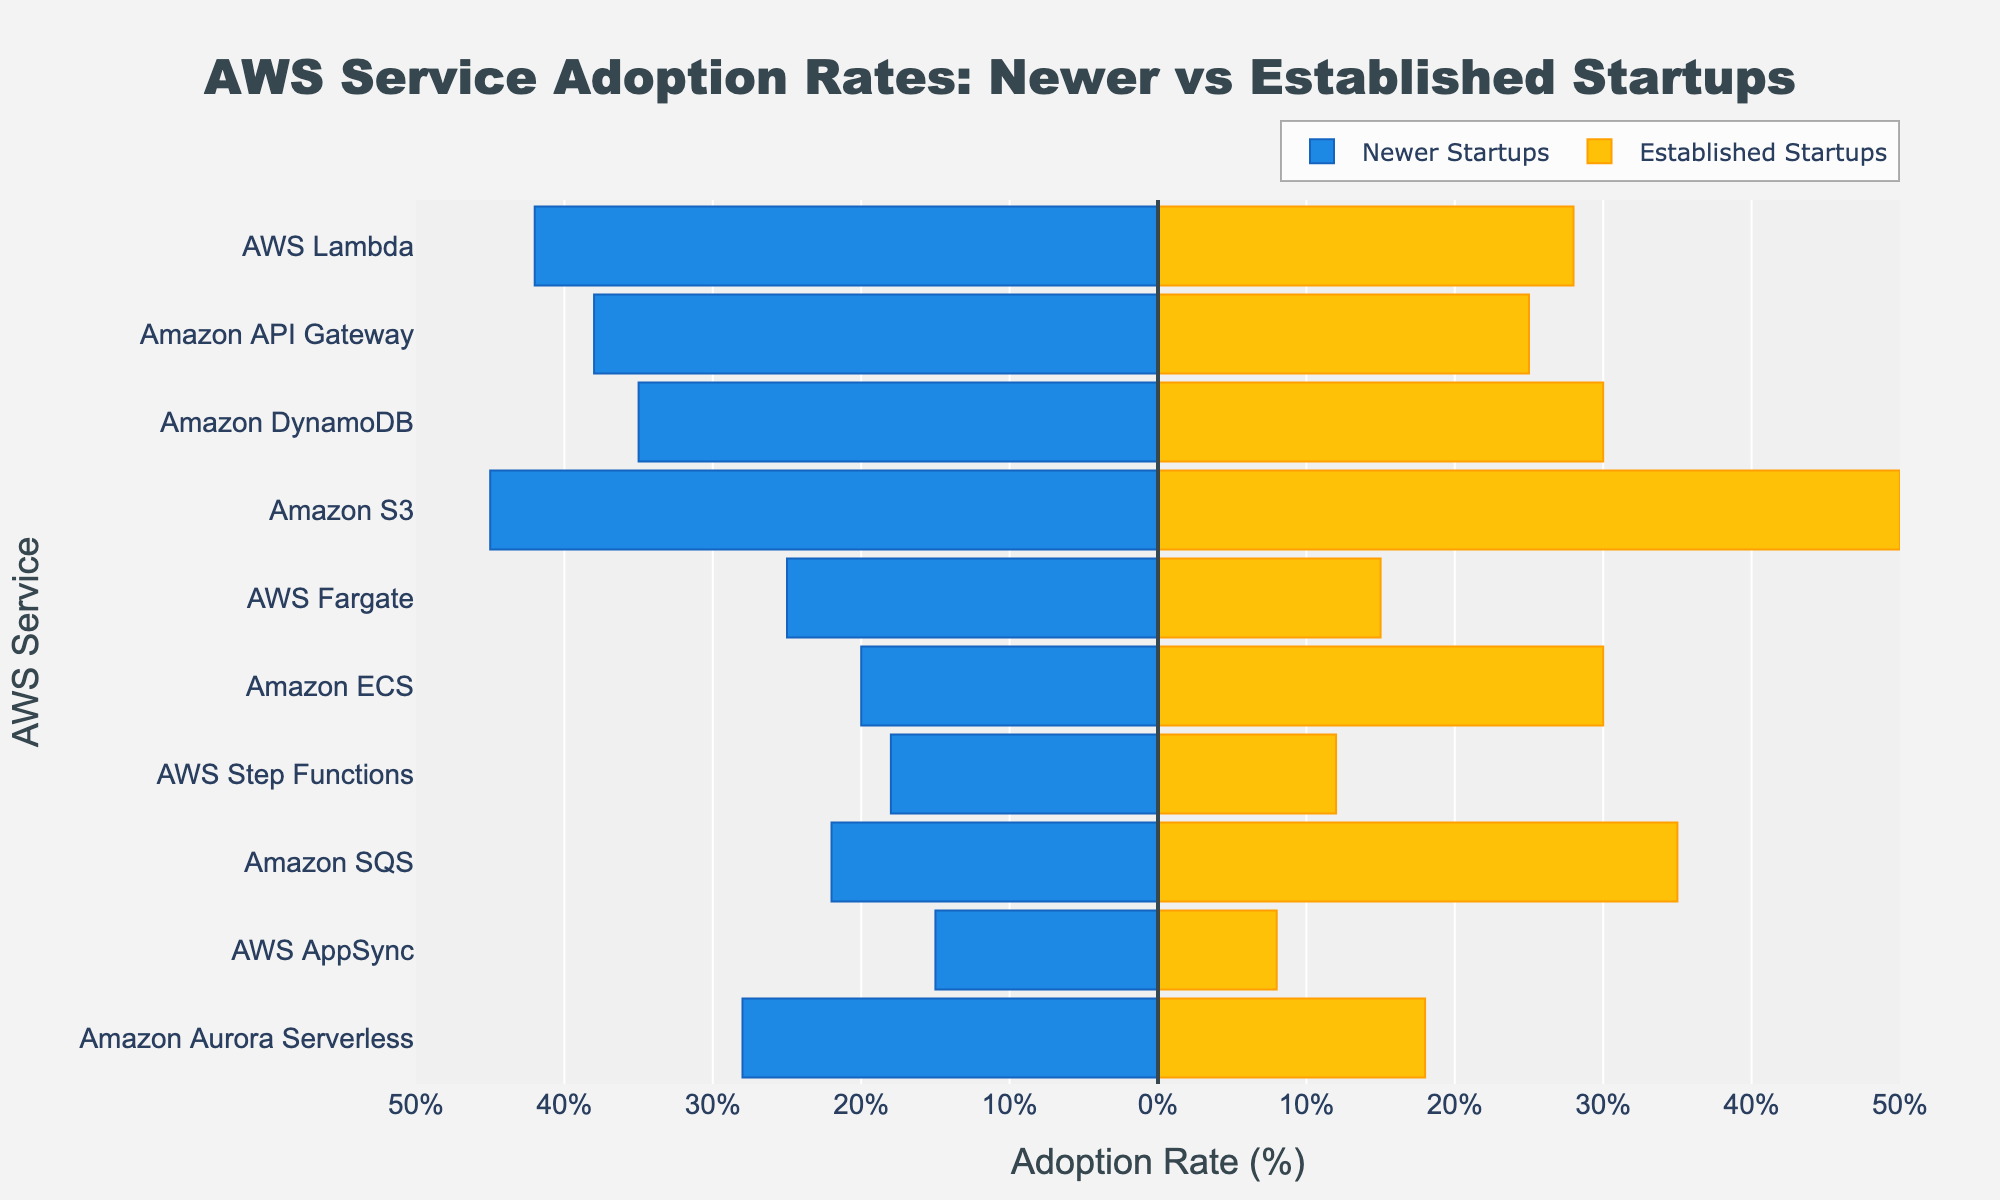What are the two AWS services with the highest adoption rates among newer startups? Look at the bar length for 'Newer Startups (%)' to find the highest values. The two longest bars are AWS Lambda (42%) and Amazon S3 (45%).
Answer: AWS Lambda and Amazon S3 Which AWS service shows a higher adoption rate among established startups than among newer startups? Compare the bars for 'Established Startups (%)' and 'Newer Startups (%)'. Amazon ECS has a higher adoption rate among established startups (30%) than newer startups (20%).
Answer: Amazon ECS For which service is the difference in adoption rates between newer and established startups the smallest? Calculate the difference for each service. AWS Step Functions has the smallest difference with a 6% difference (18% - 12%).
Answer: AWS Step Functions What is the total adoption rate percentage for newer startups across all services? Sum the absolute values of 'Newer Startups (%)'. The sum is 42 + 38 + 35 + 45 + 25 + 20 + 18 + 22 + 15 + 28 = 288.
Answer: 288% Which AWS service has the largest difference in adoption rates between newer and established startups? Calculate the difference for each service. Amazon SQS has the largest difference (35% - 22% = 13%).
Answer: Amazon SQS What is the median adoption rate for newer startups across the services? Rank the values for 'Newer Startups (%)' and pick the middle value. Ordered values: 15, 18, 20, 22, 25, 28, 35, 38, 42, 45. The median is (25+28)/2 = 26.5.
Answer: 26.5% Which AWS service is equally used by newer and established startups? Look for identical percentages in both columns. Amazon DynamoDB shows 35% for newer and established startups.
Answer: Amazon DynamoDB Which service has the largest adoption difference favoring newer startups? Compare the difference where 'Newer Startups (%)' exceeds 'Established Startups (%)'. AWS Lambda has the largest difference favoring newer startups (42% - 28% = 14%).
Answer: AWS Lambda 